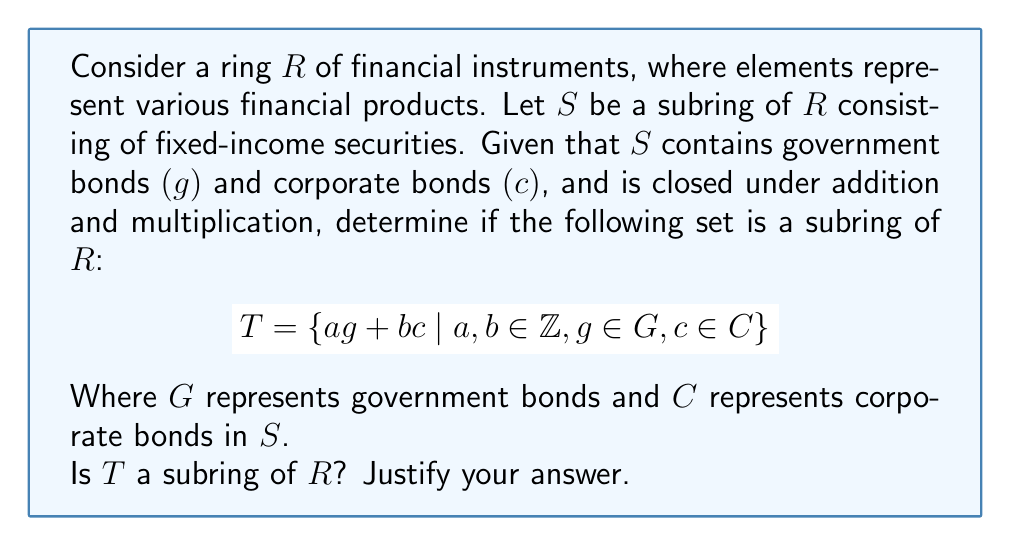Could you help me with this problem? To determine if $T$ is a subring of $R$, we need to check if it satisfies the subring criteria:

1. $T$ is non-empty
2. $T$ is closed under subtraction
3. $T$ is closed under multiplication

Step 1: $T$ is non-empty
- $T$ contains elements of the form $ag + bc$, where $a, b \in \mathbb{Z}$, $g \in G$, and $c \in C$.
- Since $G$ and $C$ are non-empty (they contain government and corporate bonds), $T$ is non-empty.

Step 2: Closure under subtraction
Let $x_1 = a_1g_1 + b_1c_1$ and $x_2 = a_2g_2 + b_2c_2$ be two elements in $T$.
$x_1 - x_2 = (a_1g_1 + b_1c_1) - (a_2g_2 + b_2c_2)$
$= a_1g_1 + b_1c_1 - a_2g_2 - b_2c_2$
$= a_1g_1 - a_2g_2 + b_1c_1 - b_2c_2$
$= (a_1g_1 - a_2g_2) + (b_1c_1 - b_2c_2)$

Since $S$ is closed under subtraction, $(a_1g_1 - a_2g_2) \in G$ and $(b_1c_1 - b_2c_2) \in C$.
Therefore, $x_1 - x_2$ is of the form $ag + bc$, where $a, b \in \mathbb{Z}$, $g \in G$, and $c \in C$.
Thus, $T$ is closed under subtraction.

Step 3: Closure under multiplication
Let $x_1 = a_1g_1 + b_1c_1$ and $x_2 = a_2g_2 + b_2c_2$ be two elements in $T$.
$x_1 \cdot x_2 = (a_1g_1 + b_1c_1)(a_2g_2 + b_2c_2)$
$= a_1a_2g_1g_2 + a_1b_2g_1c_2 + b_1a_2c_1g_2 + b_1b_2c_1c_2$

Since $S$ is closed under multiplication, $g_1g_2 \in G$, $g_1c_2 \in S$, $c_1g_2 \in S$, and $c_1c_2 \in C$.
However, the resulting expression may not be of the form $ag + bc$ where $a, b \in \mathbb{Z}$, $g \in G$, and $c \in C$.

Therefore, $T$ is not necessarily closed under multiplication.

Since $T$ fails to satisfy all three criteria for a subring, it is not a subring of $R$.
Answer: No, $T$ is not a subring of $R$. 